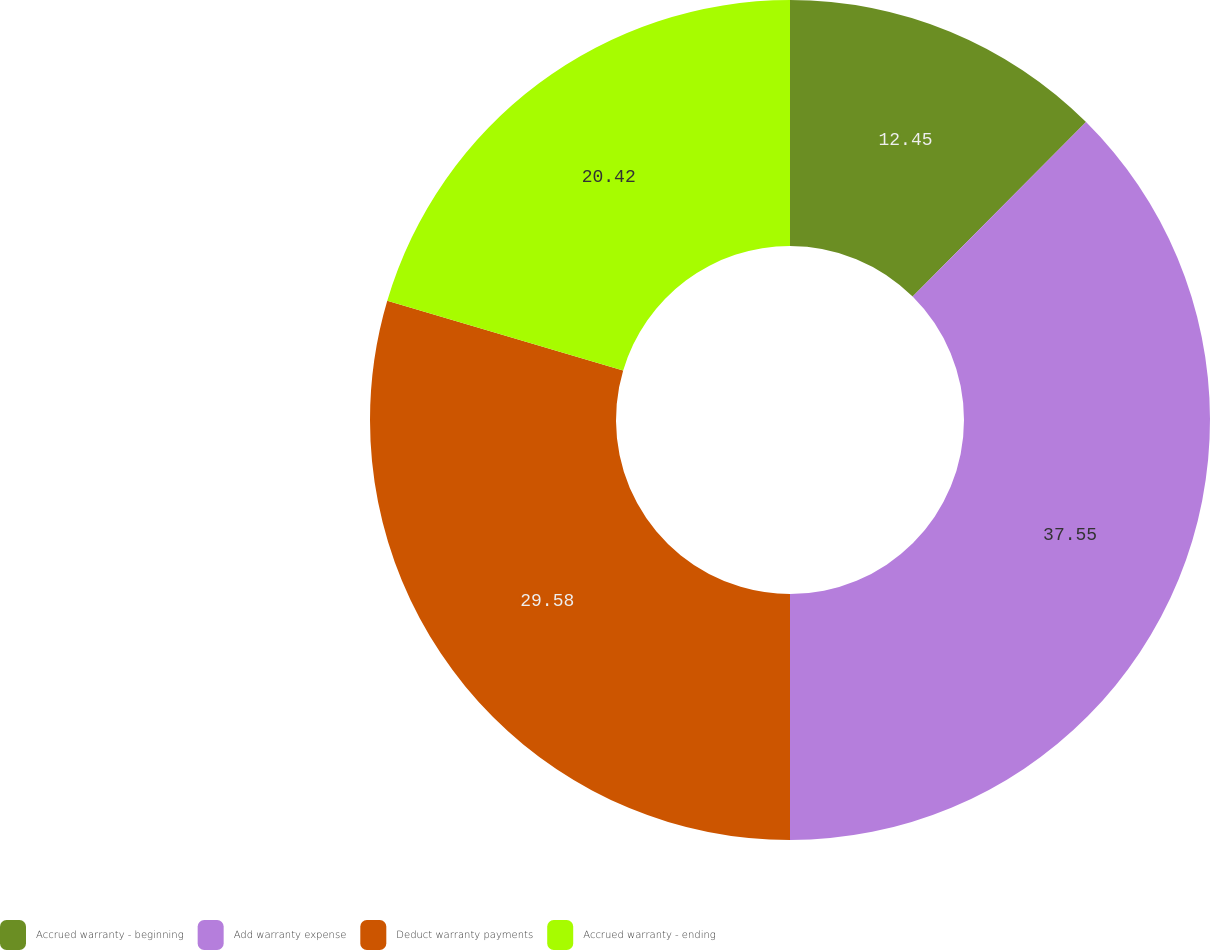<chart> <loc_0><loc_0><loc_500><loc_500><pie_chart><fcel>Accrued warranty - beginning<fcel>Add warranty expense<fcel>Deduct warranty payments<fcel>Accrued warranty - ending<nl><fcel>12.45%<fcel>37.55%<fcel>29.58%<fcel>20.42%<nl></chart> 